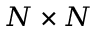Convert formula to latex. <formula><loc_0><loc_0><loc_500><loc_500>N \times N</formula> 